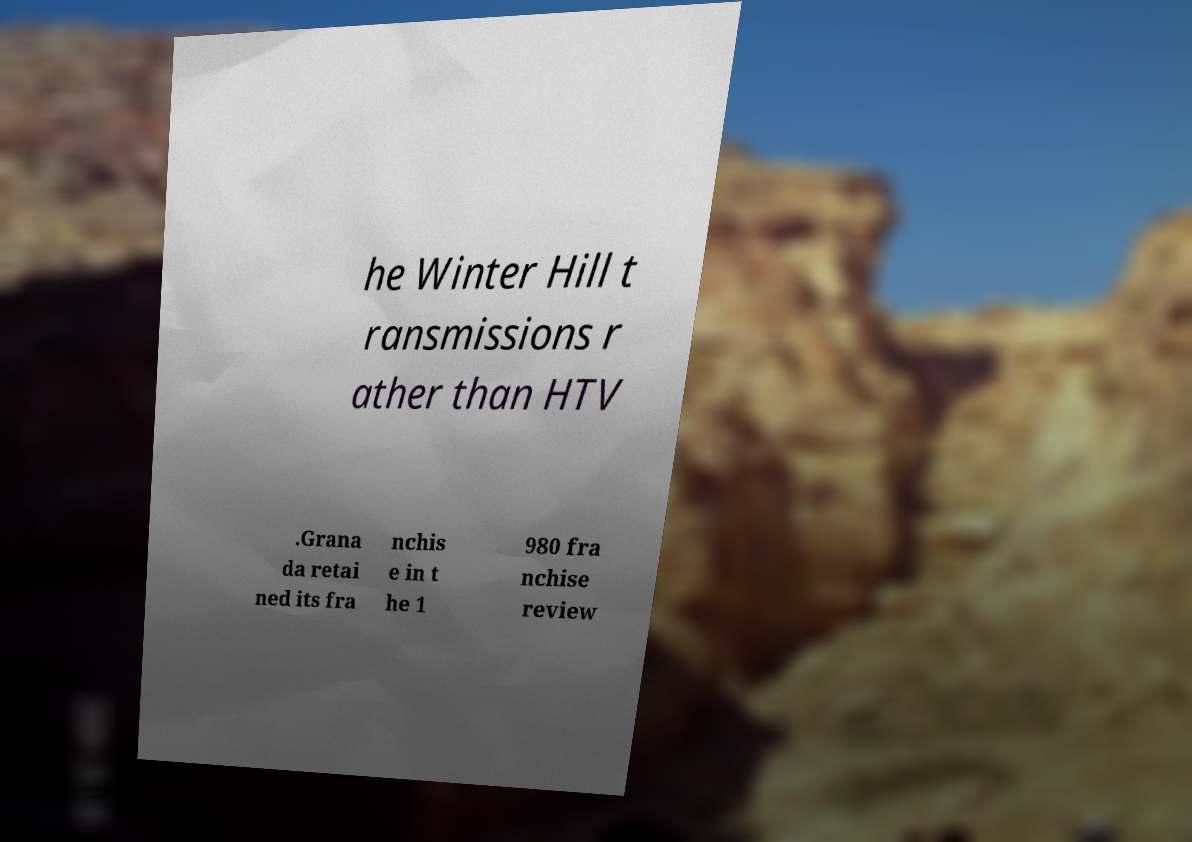Can you accurately transcribe the text from the provided image for me? he Winter Hill t ransmissions r ather than HTV .Grana da retai ned its fra nchis e in t he 1 980 fra nchise review 